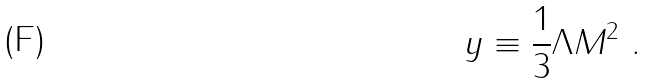<formula> <loc_0><loc_0><loc_500><loc_500>y \equiv \frac { 1 } { 3 } \Lambda M ^ { 2 } \ .</formula> 